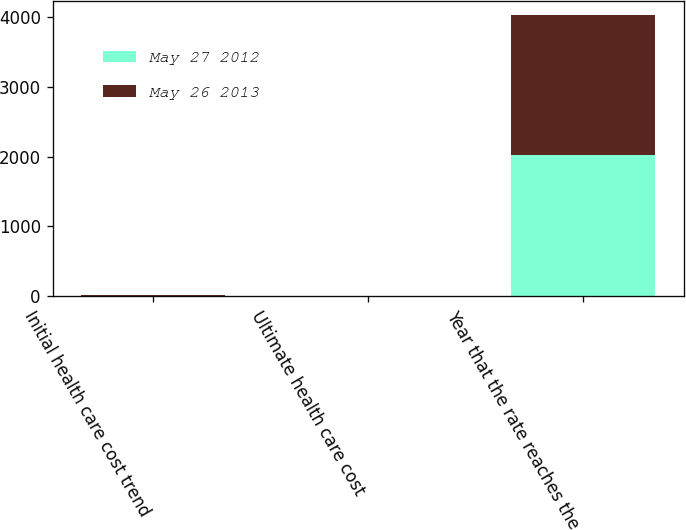Convert chart. <chart><loc_0><loc_0><loc_500><loc_500><stacked_bar_chart><ecel><fcel>Initial health care cost trend<fcel>Ultimate health care cost<fcel>Year that the rate reaches the<nl><fcel>May 27 2012<fcel>9<fcel>5<fcel>2022<nl><fcel>May 26 2013<fcel>7.5<fcel>5<fcel>2016<nl></chart> 